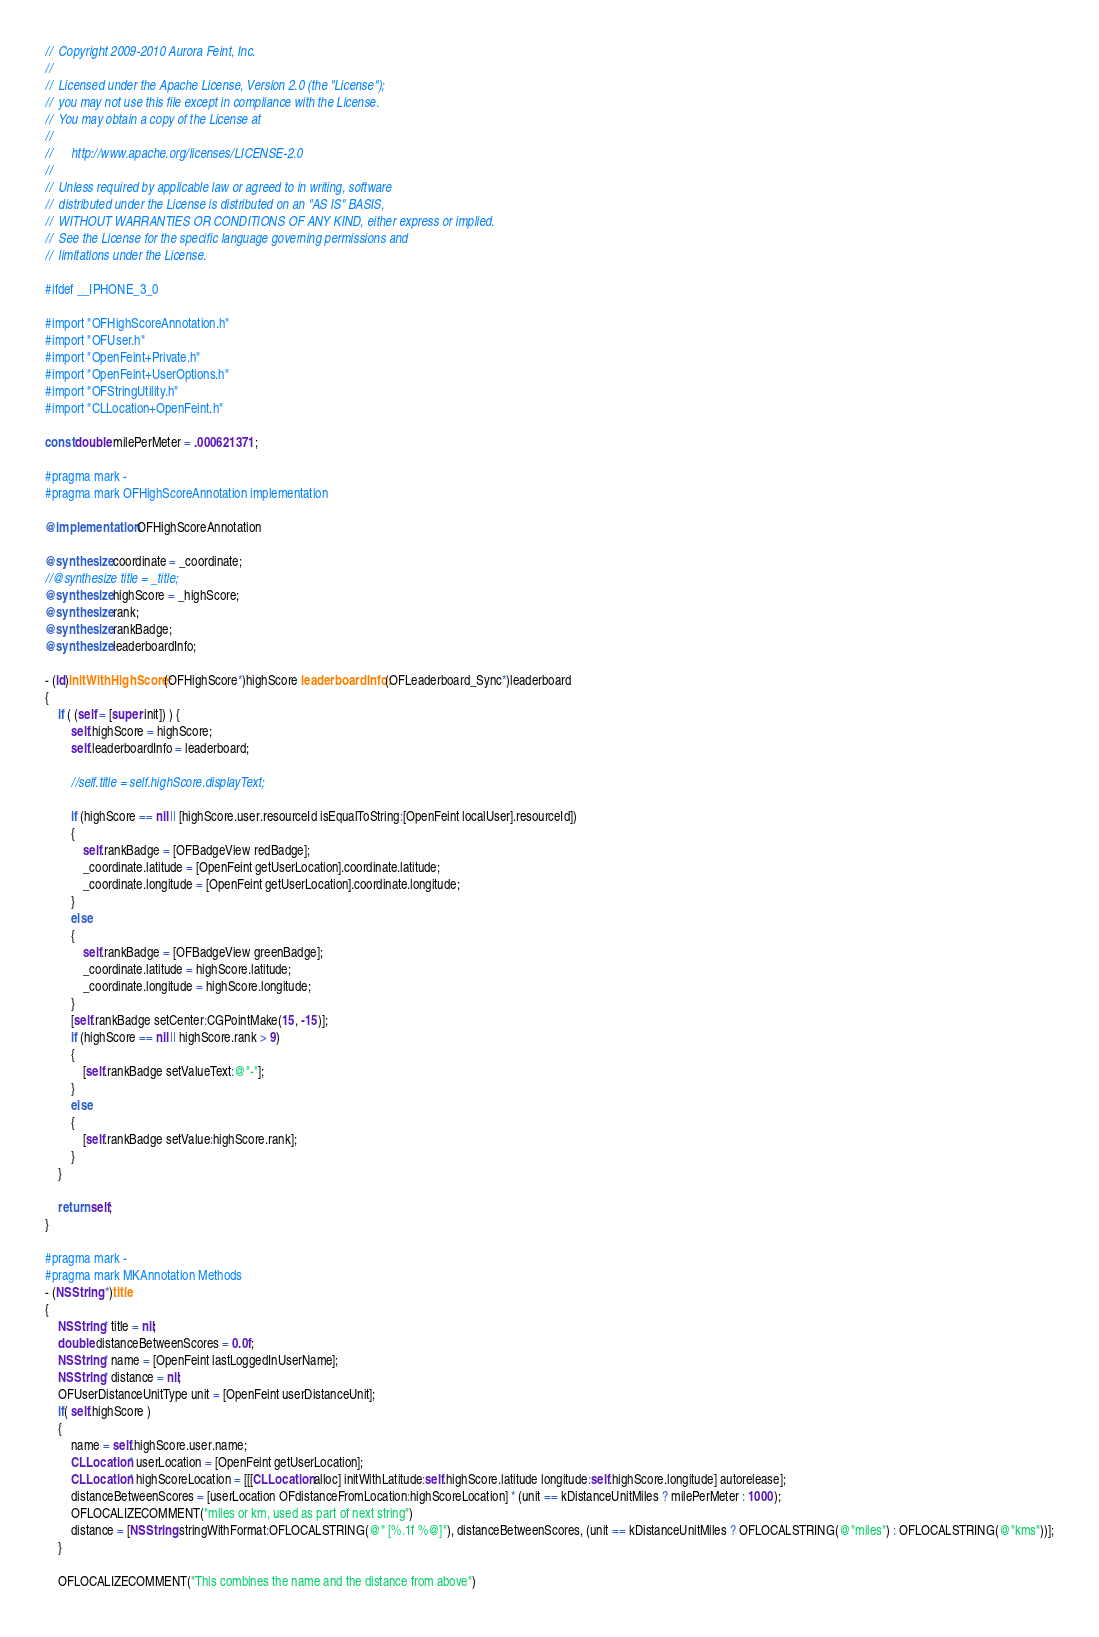Convert code to text. <code><loc_0><loc_0><loc_500><loc_500><_ObjectiveC_>//  Copyright 2009-2010 Aurora Feint, Inc.
// 
//  Licensed under the Apache License, Version 2.0 (the "License");
//  you may not use this file except in compliance with the License.
//  You may obtain a copy of the License at
//  
//  	http://www.apache.org/licenses/LICENSE-2.0
//  	
//  Unless required by applicable law or agreed to in writing, software
//  distributed under the License is distributed on an "AS IS" BASIS,
//  WITHOUT WARRANTIES OR CONDITIONS OF ANY KIND, either express or implied.
//  See the License for the specific language governing permissions and
//  limitations under the License.

#ifdef __IPHONE_3_0

#import "OFHighScoreAnnotation.h"
#import "OFUser.h"
#import "OpenFeint+Private.h"
#import "OpenFeint+UserOptions.h"
#import "OFStringUtility.h"
#import "CLLocation+OpenFeint.h"

const double milePerMeter = .000621371;

#pragma mark -
#pragma mark OFHighScoreAnnotation implementation

@implementation OFHighScoreAnnotation

@synthesize coordinate = _coordinate;
//@synthesize title = _title;
@synthesize highScore = _highScore;
@synthesize rank;
@synthesize rankBadge;
@synthesize leaderboardInfo;

- (id)initWithHighScore:(OFHighScore*)highScore leaderboardInfo:(OFLeaderboard_Sync*)leaderboard 
{
	if ( (self = [super init]) ) {
		self.highScore = highScore;
		self.leaderboardInfo = leaderboard;
		
		//self.title = self.highScore.displayText;
		
		if (highScore == nil || [highScore.user.resourceId isEqualToString:[OpenFeint localUser].resourceId])
		{
			self.rankBadge = [OFBadgeView redBadge];
			_coordinate.latitude = [OpenFeint getUserLocation].coordinate.latitude;
			_coordinate.longitude = [OpenFeint getUserLocation].coordinate.longitude;
		}
		else
		{
			self.rankBadge = [OFBadgeView greenBadge];
			_coordinate.latitude = highScore.latitude;
			_coordinate.longitude = highScore.longitude;
		}
		[self.rankBadge setCenter:CGPointMake(15, -15)];
		if (highScore == nil || highScore.rank > 9)
		{
			[self.rankBadge setValueText:@"-"];
		}
		else
		{
			[self.rankBadge setValue:highScore.rank];
		}
	}

	return self;
}

#pragma mark -
#pragma mark MKAnnotation Methods
- (NSString *)title 
{
	NSString* title = nil;
	double distanceBetweenScores = 0.0f;
	NSString* name = [OpenFeint lastLoggedInUserName];
	NSString* distance = nil;
	OFUserDistanceUnitType unit = [OpenFeint userDistanceUnit];
	if( self.highScore )
	{
		name = self.highScore.user.name;
		CLLocation* userLocation = [OpenFeint getUserLocation];
		CLLocation* highScoreLocation = [[[CLLocation alloc] initWithLatitude:self.highScore.latitude longitude:self.highScore.longitude] autorelease];
		distanceBetweenScores = [userLocation OFdistanceFromLocation:highScoreLocation] * (unit == kDistanceUnitMiles ? milePerMeter : 1000);
        OFLOCALIZECOMMENT("miles or km, used as part of next string")
		distance = [NSString stringWithFormat:OFLOCALSTRING(@" [%.1f %@]"), distanceBetweenScores, (unit == kDistanceUnitMiles ? OFLOCALSTRING(@"miles") : OFLOCALSTRING(@"kms"))];
	}
	
    OFLOCALIZECOMMENT("This combines the name and the distance from above")</code> 